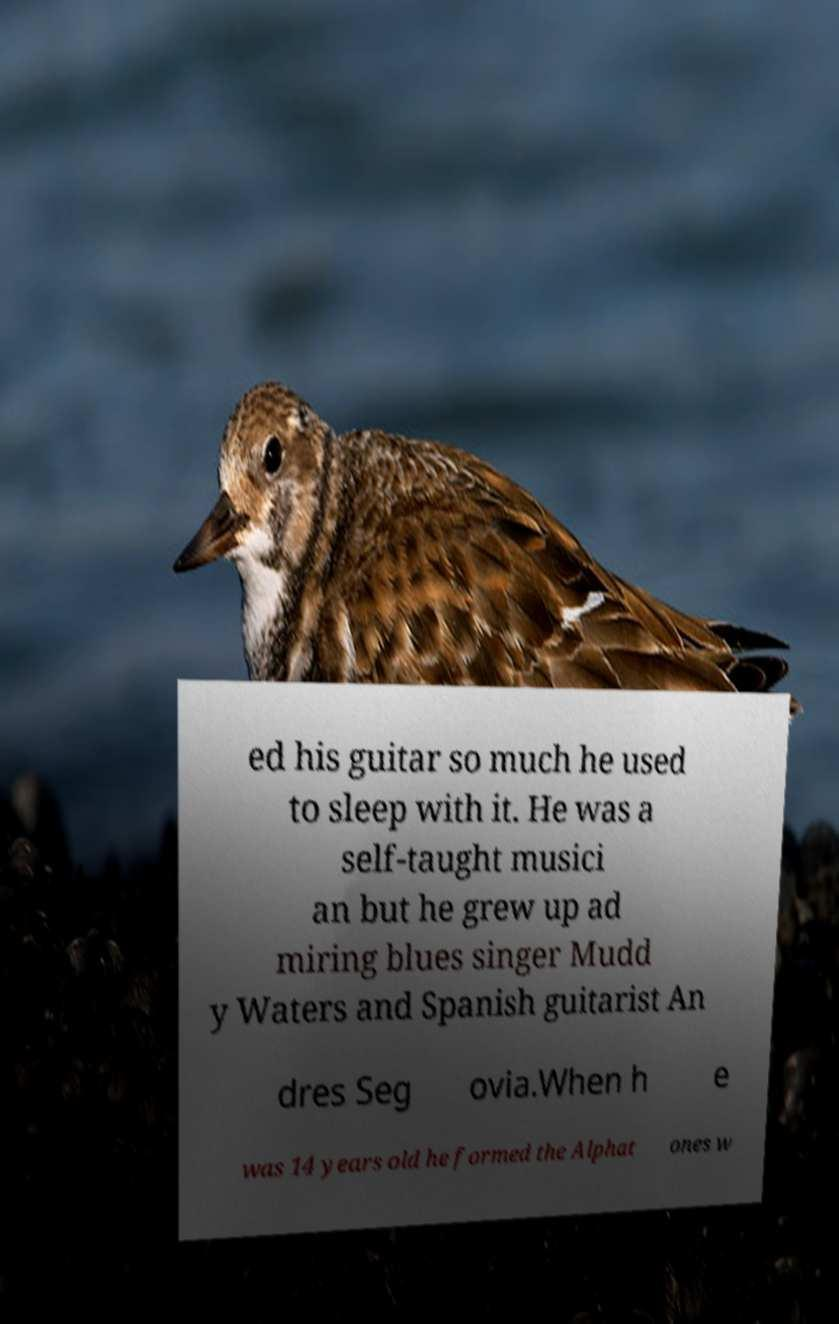What messages or text are displayed in this image? I need them in a readable, typed format. ed his guitar so much he used to sleep with it. He was a self-taught musici an but he grew up ad miring blues singer Mudd y Waters and Spanish guitarist An dres Seg ovia.When h e was 14 years old he formed the Alphat ones w 